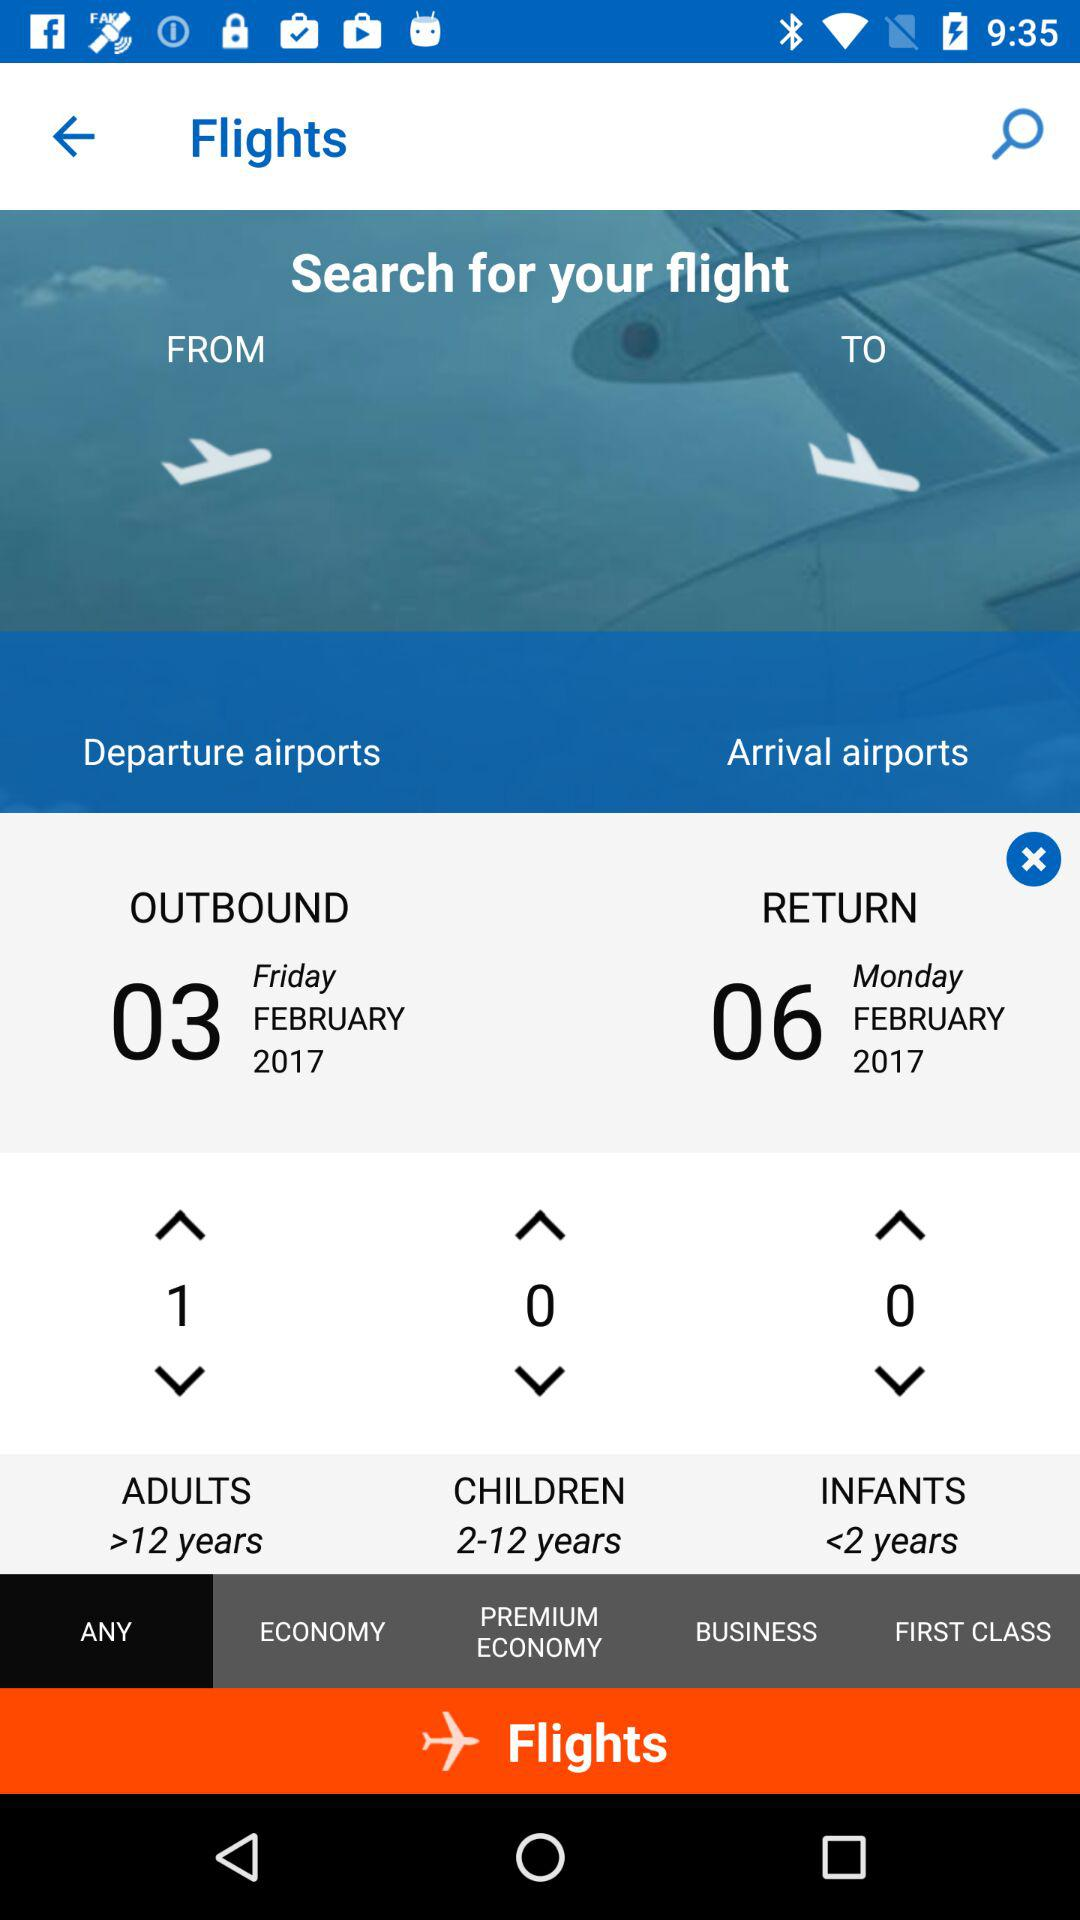In which category will people over 12 years come? People over 12 years old would come under the "ADULTS" category. 